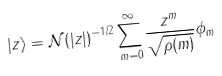<formula> <loc_0><loc_0><loc_500><loc_500>| z \rangle = \mathcal { N } ( | z | ) ^ { - 1 / 2 } \sum _ { m = 0 } ^ { \infty } \frac { z ^ { m } } { \sqrt { \rho ( m ) } } \phi _ { m }</formula> 